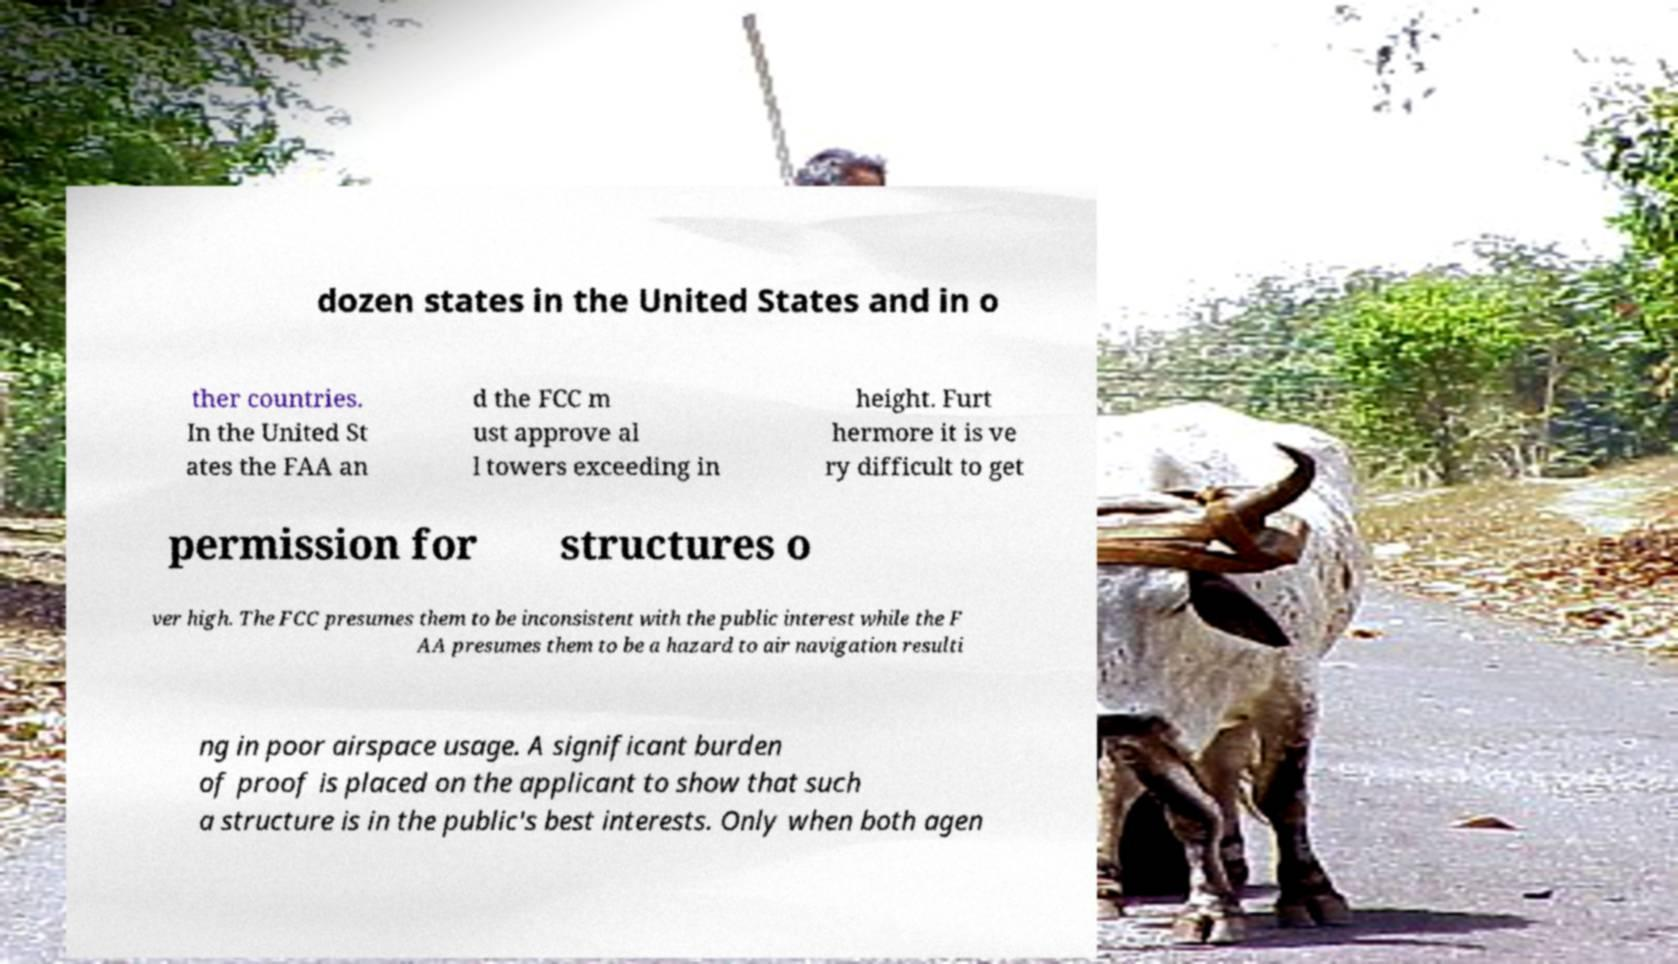Could you extract and type out the text from this image? dozen states in the United States and in o ther countries. In the United St ates the FAA an d the FCC m ust approve al l towers exceeding in height. Furt hermore it is ve ry difficult to get permission for structures o ver high. The FCC presumes them to be inconsistent with the public interest while the F AA presumes them to be a hazard to air navigation resulti ng in poor airspace usage. A significant burden of proof is placed on the applicant to show that such a structure is in the public's best interests. Only when both agen 